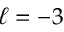Convert formula to latex. <formula><loc_0><loc_0><loc_500><loc_500>\ell = - 3</formula> 